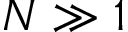Convert formula to latex. <formula><loc_0><loc_0><loc_500><loc_500>N \gg 1</formula> 